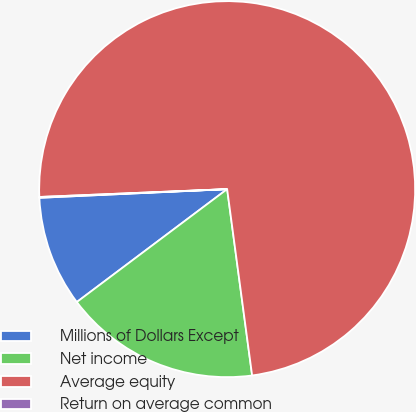<chart> <loc_0><loc_0><loc_500><loc_500><pie_chart><fcel>Millions of Dollars Except<fcel>Net income<fcel>Average equity<fcel>Return on average common<nl><fcel>9.52%<fcel>16.87%<fcel>73.55%<fcel>0.07%<nl></chart> 